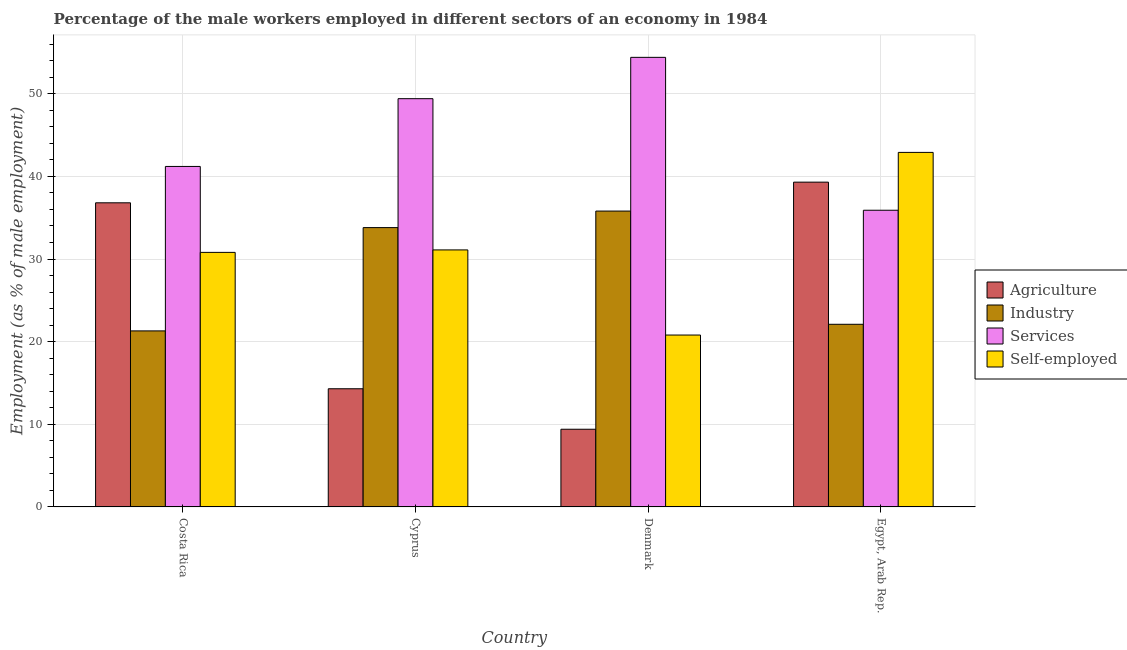How many groups of bars are there?
Offer a terse response. 4. What is the label of the 2nd group of bars from the left?
Provide a short and direct response. Cyprus. In how many cases, is the number of bars for a given country not equal to the number of legend labels?
Your answer should be compact. 0. What is the percentage of male workers in industry in Egypt, Arab Rep.?
Your answer should be very brief. 22.1. Across all countries, what is the maximum percentage of male workers in industry?
Ensure brevity in your answer.  35.8. Across all countries, what is the minimum percentage of self employed male workers?
Keep it short and to the point. 20.8. In which country was the percentage of male workers in services maximum?
Ensure brevity in your answer.  Denmark. In which country was the percentage of self employed male workers minimum?
Give a very brief answer. Denmark. What is the total percentage of male workers in industry in the graph?
Offer a very short reply. 113. What is the difference between the percentage of male workers in agriculture in Costa Rica and that in Denmark?
Offer a very short reply. 27.4. What is the difference between the percentage of self employed male workers in Denmark and the percentage of male workers in industry in Egypt, Arab Rep.?
Provide a succinct answer. -1.3. What is the average percentage of male workers in industry per country?
Offer a very short reply. 28.25. What is the difference between the percentage of male workers in services and percentage of male workers in industry in Egypt, Arab Rep.?
Your answer should be very brief. 13.8. In how many countries, is the percentage of male workers in agriculture greater than 36 %?
Offer a very short reply. 2. What is the ratio of the percentage of self employed male workers in Cyprus to that in Denmark?
Offer a terse response. 1.5. Is the difference between the percentage of male workers in industry in Cyprus and Egypt, Arab Rep. greater than the difference between the percentage of male workers in agriculture in Cyprus and Egypt, Arab Rep.?
Offer a terse response. Yes. What is the difference between the highest and the lowest percentage of male workers in agriculture?
Offer a very short reply. 29.9. In how many countries, is the percentage of male workers in services greater than the average percentage of male workers in services taken over all countries?
Offer a terse response. 2. Is the sum of the percentage of male workers in agriculture in Costa Rica and Denmark greater than the maximum percentage of self employed male workers across all countries?
Give a very brief answer. Yes. What does the 4th bar from the left in Egypt, Arab Rep. represents?
Ensure brevity in your answer.  Self-employed. What does the 3rd bar from the right in Costa Rica represents?
Make the answer very short. Industry. How many countries are there in the graph?
Give a very brief answer. 4. What is the difference between two consecutive major ticks on the Y-axis?
Provide a short and direct response. 10. Does the graph contain any zero values?
Make the answer very short. No. Where does the legend appear in the graph?
Offer a terse response. Center right. How many legend labels are there?
Provide a short and direct response. 4. How are the legend labels stacked?
Your answer should be very brief. Vertical. What is the title of the graph?
Your response must be concise. Percentage of the male workers employed in different sectors of an economy in 1984. What is the label or title of the Y-axis?
Offer a very short reply. Employment (as % of male employment). What is the Employment (as % of male employment) of Agriculture in Costa Rica?
Give a very brief answer. 36.8. What is the Employment (as % of male employment) of Industry in Costa Rica?
Your response must be concise. 21.3. What is the Employment (as % of male employment) of Services in Costa Rica?
Your answer should be compact. 41.2. What is the Employment (as % of male employment) in Self-employed in Costa Rica?
Provide a succinct answer. 30.8. What is the Employment (as % of male employment) of Agriculture in Cyprus?
Offer a terse response. 14.3. What is the Employment (as % of male employment) of Industry in Cyprus?
Your answer should be compact. 33.8. What is the Employment (as % of male employment) of Services in Cyprus?
Your answer should be very brief. 49.4. What is the Employment (as % of male employment) of Self-employed in Cyprus?
Offer a terse response. 31.1. What is the Employment (as % of male employment) in Agriculture in Denmark?
Make the answer very short. 9.4. What is the Employment (as % of male employment) of Industry in Denmark?
Your answer should be very brief. 35.8. What is the Employment (as % of male employment) of Services in Denmark?
Your answer should be very brief. 54.4. What is the Employment (as % of male employment) of Self-employed in Denmark?
Keep it short and to the point. 20.8. What is the Employment (as % of male employment) in Agriculture in Egypt, Arab Rep.?
Your answer should be compact. 39.3. What is the Employment (as % of male employment) in Industry in Egypt, Arab Rep.?
Your response must be concise. 22.1. What is the Employment (as % of male employment) of Services in Egypt, Arab Rep.?
Keep it short and to the point. 35.9. What is the Employment (as % of male employment) in Self-employed in Egypt, Arab Rep.?
Make the answer very short. 42.9. Across all countries, what is the maximum Employment (as % of male employment) in Agriculture?
Offer a very short reply. 39.3. Across all countries, what is the maximum Employment (as % of male employment) in Industry?
Provide a succinct answer. 35.8. Across all countries, what is the maximum Employment (as % of male employment) in Services?
Your answer should be very brief. 54.4. Across all countries, what is the maximum Employment (as % of male employment) of Self-employed?
Provide a short and direct response. 42.9. Across all countries, what is the minimum Employment (as % of male employment) of Agriculture?
Provide a succinct answer. 9.4. Across all countries, what is the minimum Employment (as % of male employment) in Industry?
Your response must be concise. 21.3. Across all countries, what is the minimum Employment (as % of male employment) of Services?
Offer a terse response. 35.9. Across all countries, what is the minimum Employment (as % of male employment) of Self-employed?
Offer a terse response. 20.8. What is the total Employment (as % of male employment) in Agriculture in the graph?
Offer a terse response. 99.8. What is the total Employment (as % of male employment) in Industry in the graph?
Ensure brevity in your answer.  113. What is the total Employment (as % of male employment) in Services in the graph?
Your answer should be compact. 180.9. What is the total Employment (as % of male employment) in Self-employed in the graph?
Make the answer very short. 125.6. What is the difference between the Employment (as % of male employment) of Industry in Costa Rica and that in Cyprus?
Your answer should be very brief. -12.5. What is the difference between the Employment (as % of male employment) of Self-employed in Costa Rica and that in Cyprus?
Your response must be concise. -0.3. What is the difference between the Employment (as % of male employment) in Agriculture in Costa Rica and that in Denmark?
Your answer should be compact. 27.4. What is the difference between the Employment (as % of male employment) of Services in Costa Rica and that in Denmark?
Your answer should be very brief. -13.2. What is the difference between the Employment (as % of male employment) in Self-employed in Costa Rica and that in Denmark?
Ensure brevity in your answer.  10. What is the difference between the Employment (as % of male employment) in Self-employed in Costa Rica and that in Egypt, Arab Rep.?
Your answer should be very brief. -12.1. What is the difference between the Employment (as % of male employment) of Agriculture in Cyprus and that in Denmark?
Your answer should be very brief. 4.9. What is the difference between the Employment (as % of male employment) of Industry in Cyprus and that in Denmark?
Give a very brief answer. -2. What is the difference between the Employment (as % of male employment) in Services in Cyprus and that in Denmark?
Your answer should be very brief. -5. What is the difference between the Employment (as % of male employment) of Self-employed in Cyprus and that in Denmark?
Your response must be concise. 10.3. What is the difference between the Employment (as % of male employment) in Agriculture in Cyprus and that in Egypt, Arab Rep.?
Provide a short and direct response. -25. What is the difference between the Employment (as % of male employment) of Services in Cyprus and that in Egypt, Arab Rep.?
Give a very brief answer. 13.5. What is the difference between the Employment (as % of male employment) of Self-employed in Cyprus and that in Egypt, Arab Rep.?
Offer a very short reply. -11.8. What is the difference between the Employment (as % of male employment) of Agriculture in Denmark and that in Egypt, Arab Rep.?
Ensure brevity in your answer.  -29.9. What is the difference between the Employment (as % of male employment) in Services in Denmark and that in Egypt, Arab Rep.?
Your answer should be compact. 18.5. What is the difference between the Employment (as % of male employment) of Self-employed in Denmark and that in Egypt, Arab Rep.?
Your answer should be compact. -22.1. What is the difference between the Employment (as % of male employment) of Industry in Costa Rica and the Employment (as % of male employment) of Services in Cyprus?
Your answer should be very brief. -28.1. What is the difference between the Employment (as % of male employment) in Industry in Costa Rica and the Employment (as % of male employment) in Self-employed in Cyprus?
Give a very brief answer. -9.8. What is the difference between the Employment (as % of male employment) in Agriculture in Costa Rica and the Employment (as % of male employment) in Services in Denmark?
Keep it short and to the point. -17.6. What is the difference between the Employment (as % of male employment) in Industry in Costa Rica and the Employment (as % of male employment) in Services in Denmark?
Your response must be concise. -33.1. What is the difference between the Employment (as % of male employment) in Industry in Costa Rica and the Employment (as % of male employment) in Self-employed in Denmark?
Offer a terse response. 0.5. What is the difference between the Employment (as % of male employment) of Services in Costa Rica and the Employment (as % of male employment) of Self-employed in Denmark?
Offer a very short reply. 20.4. What is the difference between the Employment (as % of male employment) in Agriculture in Costa Rica and the Employment (as % of male employment) in Industry in Egypt, Arab Rep.?
Your answer should be compact. 14.7. What is the difference between the Employment (as % of male employment) in Industry in Costa Rica and the Employment (as % of male employment) in Services in Egypt, Arab Rep.?
Provide a succinct answer. -14.6. What is the difference between the Employment (as % of male employment) in Industry in Costa Rica and the Employment (as % of male employment) in Self-employed in Egypt, Arab Rep.?
Keep it short and to the point. -21.6. What is the difference between the Employment (as % of male employment) in Agriculture in Cyprus and the Employment (as % of male employment) in Industry in Denmark?
Offer a very short reply. -21.5. What is the difference between the Employment (as % of male employment) of Agriculture in Cyprus and the Employment (as % of male employment) of Services in Denmark?
Your response must be concise. -40.1. What is the difference between the Employment (as % of male employment) in Industry in Cyprus and the Employment (as % of male employment) in Services in Denmark?
Provide a short and direct response. -20.6. What is the difference between the Employment (as % of male employment) of Industry in Cyprus and the Employment (as % of male employment) of Self-employed in Denmark?
Your response must be concise. 13. What is the difference between the Employment (as % of male employment) of Services in Cyprus and the Employment (as % of male employment) of Self-employed in Denmark?
Provide a short and direct response. 28.6. What is the difference between the Employment (as % of male employment) of Agriculture in Cyprus and the Employment (as % of male employment) of Services in Egypt, Arab Rep.?
Your answer should be compact. -21.6. What is the difference between the Employment (as % of male employment) in Agriculture in Cyprus and the Employment (as % of male employment) in Self-employed in Egypt, Arab Rep.?
Make the answer very short. -28.6. What is the difference between the Employment (as % of male employment) in Industry in Cyprus and the Employment (as % of male employment) in Self-employed in Egypt, Arab Rep.?
Give a very brief answer. -9.1. What is the difference between the Employment (as % of male employment) in Services in Cyprus and the Employment (as % of male employment) in Self-employed in Egypt, Arab Rep.?
Your answer should be compact. 6.5. What is the difference between the Employment (as % of male employment) of Agriculture in Denmark and the Employment (as % of male employment) of Services in Egypt, Arab Rep.?
Your answer should be very brief. -26.5. What is the difference between the Employment (as % of male employment) of Agriculture in Denmark and the Employment (as % of male employment) of Self-employed in Egypt, Arab Rep.?
Give a very brief answer. -33.5. What is the difference between the Employment (as % of male employment) of Industry in Denmark and the Employment (as % of male employment) of Services in Egypt, Arab Rep.?
Make the answer very short. -0.1. What is the difference between the Employment (as % of male employment) of Services in Denmark and the Employment (as % of male employment) of Self-employed in Egypt, Arab Rep.?
Keep it short and to the point. 11.5. What is the average Employment (as % of male employment) of Agriculture per country?
Offer a terse response. 24.95. What is the average Employment (as % of male employment) in Industry per country?
Provide a succinct answer. 28.25. What is the average Employment (as % of male employment) in Services per country?
Your response must be concise. 45.23. What is the average Employment (as % of male employment) of Self-employed per country?
Provide a short and direct response. 31.4. What is the difference between the Employment (as % of male employment) of Agriculture and Employment (as % of male employment) of Services in Costa Rica?
Make the answer very short. -4.4. What is the difference between the Employment (as % of male employment) of Industry and Employment (as % of male employment) of Services in Costa Rica?
Your answer should be very brief. -19.9. What is the difference between the Employment (as % of male employment) in Agriculture and Employment (as % of male employment) in Industry in Cyprus?
Your answer should be very brief. -19.5. What is the difference between the Employment (as % of male employment) of Agriculture and Employment (as % of male employment) of Services in Cyprus?
Your answer should be very brief. -35.1. What is the difference between the Employment (as % of male employment) of Agriculture and Employment (as % of male employment) of Self-employed in Cyprus?
Keep it short and to the point. -16.8. What is the difference between the Employment (as % of male employment) of Industry and Employment (as % of male employment) of Services in Cyprus?
Ensure brevity in your answer.  -15.6. What is the difference between the Employment (as % of male employment) of Industry and Employment (as % of male employment) of Self-employed in Cyprus?
Offer a very short reply. 2.7. What is the difference between the Employment (as % of male employment) of Agriculture and Employment (as % of male employment) of Industry in Denmark?
Ensure brevity in your answer.  -26.4. What is the difference between the Employment (as % of male employment) of Agriculture and Employment (as % of male employment) of Services in Denmark?
Give a very brief answer. -45. What is the difference between the Employment (as % of male employment) in Industry and Employment (as % of male employment) in Services in Denmark?
Your answer should be compact. -18.6. What is the difference between the Employment (as % of male employment) in Services and Employment (as % of male employment) in Self-employed in Denmark?
Offer a very short reply. 33.6. What is the difference between the Employment (as % of male employment) in Agriculture and Employment (as % of male employment) in Industry in Egypt, Arab Rep.?
Offer a very short reply. 17.2. What is the difference between the Employment (as % of male employment) in Agriculture and Employment (as % of male employment) in Services in Egypt, Arab Rep.?
Your answer should be compact. 3.4. What is the difference between the Employment (as % of male employment) of Agriculture and Employment (as % of male employment) of Self-employed in Egypt, Arab Rep.?
Offer a very short reply. -3.6. What is the difference between the Employment (as % of male employment) in Industry and Employment (as % of male employment) in Self-employed in Egypt, Arab Rep.?
Provide a succinct answer. -20.8. What is the ratio of the Employment (as % of male employment) in Agriculture in Costa Rica to that in Cyprus?
Provide a short and direct response. 2.57. What is the ratio of the Employment (as % of male employment) of Industry in Costa Rica to that in Cyprus?
Your answer should be compact. 0.63. What is the ratio of the Employment (as % of male employment) in Services in Costa Rica to that in Cyprus?
Your answer should be compact. 0.83. What is the ratio of the Employment (as % of male employment) in Self-employed in Costa Rica to that in Cyprus?
Your answer should be compact. 0.99. What is the ratio of the Employment (as % of male employment) of Agriculture in Costa Rica to that in Denmark?
Your answer should be compact. 3.91. What is the ratio of the Employment (as % of male employment) of Industry in Costa Rica to that in Denmark?
Offer a terse response. 0.59. What is the ratio of the Employment (as % of male employment) of Services in Costa Rica to that in Denmark?
Your answer should be compact. 0.76. What is the ratio of the Employment (as % of male employment) of Self-employed in Costa Rica to that in Denmark?
Make the answer very short. 1.48. What is the ratio of the Employment (as % of male employment) in Agriculture in Costa Rica to that in Egypt, Arab Rep.?
Provide a succinct answer. 0.94. What is the ratio of the Employment (as % of male employment) of Industry in Costa Rica to that in Egypt, Arab Rep.?
Keep it short and to the point. 0.96. What is the ratio of the Employment (as % of male employment) of Services in Costa Rica to that in Egypt, Arab Rep.?
Your answer should be compact. 1.15. What is the ratio of the Employment (as % of male employment) in Self-employed in Costa Rica to that in Egypt, Arab Rep.?
Ensure brevity in your answer.  0.72. What is the ratio of the Employment (as % of male employment) in Agriculture in Cyprus to that in Denmark?
Keep it short and to the point. 1.52. What is the ratio of the Employment (as % of male employment) in Industry in Cyprus to that in Denmark?
Provide a short and direct response. 0.94. What is the ratio of the Employment (as % of male employment) of Services in Cyprus to that in Denmark?
Offer a terse response. 0.91. What is the ratio of the Employment (as % of male employment) of Self-employed in Cyprus to that in Denmark?
Offer a terse response. 1.5. What is the ratio of the Employment (as % of male employment) of Agriculture in Cyprus to that in Egypt, Arab Rep.?
Provide a short and direct response. 0.36. What is the ratio of the Employment (as % of male employment) of Industry in Cyprus to that in Egypt, Arab Rep.?
Ensure brevity in your answer.  1.53. What is the ratio of the Employment (as % of male employment) of Services in Cyprus to that in Egypt, Arab Rep.?
Offer a terse response. 1.38. What is the ratio of the Employment (as % of male employment) of Self-employed in Cyprus to that in Egypt, Arab Rep.?
Provide a short and direct response. 0.72. What is the ratio of the Employment (as % of male employment) in Agriculture in Denmark to that in Egypt, Arab Rep.?
Give a very brief answer. 0.24. What is the ratio of the Employment (as % of male employment) in Industry in Denmark to that in Egypt, Arab Rep.?
Your answer should be compact. 1.62. What is the ratio of the Employment (as % of male employment) in Services in Denmark to that in Egypt, Arab Rep.?
Make the answer very short. 1.52. What is the ratio of the Employment (as % of male employment) of Self-employed in Denmark to that in Egypt, Arab Rep.?
Make the answer very short. 0.48. What is the difference between the highest and the second highest Employment (as % of male employment) in Industry?
Ensure brevity in your answer.  2. What is the difference between the highest and the lowest Employment (as % of male employment) in Agriculture?
Keep it short and to the point. 29.9. What is the difference between the highest and the lowest Employment (as % of male employment) of Services?
Your answer should be very brief. 18.5. What is the difference between the highest and the lowest Employment (as % of male employment) in Self-employed?
Your response must be concise. 22.1. 